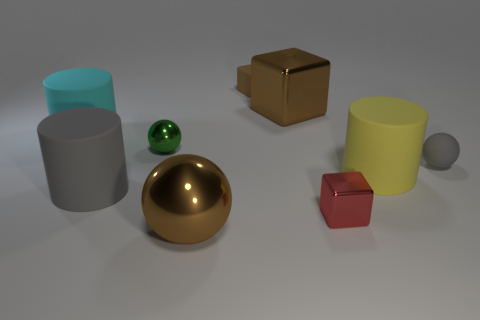Add 1 large objects. How many objects exist? 10 Add 3 green balls. How many green balls are left? 4 Add 9 big brown metallic cubes. How many big brown metallic cubes exist? 10 Subtract 0 blue spheres. How many objects are left? 9 Subtract all large gray rubber cylinders. Subtract all red cubes. How many objects are left? 7 